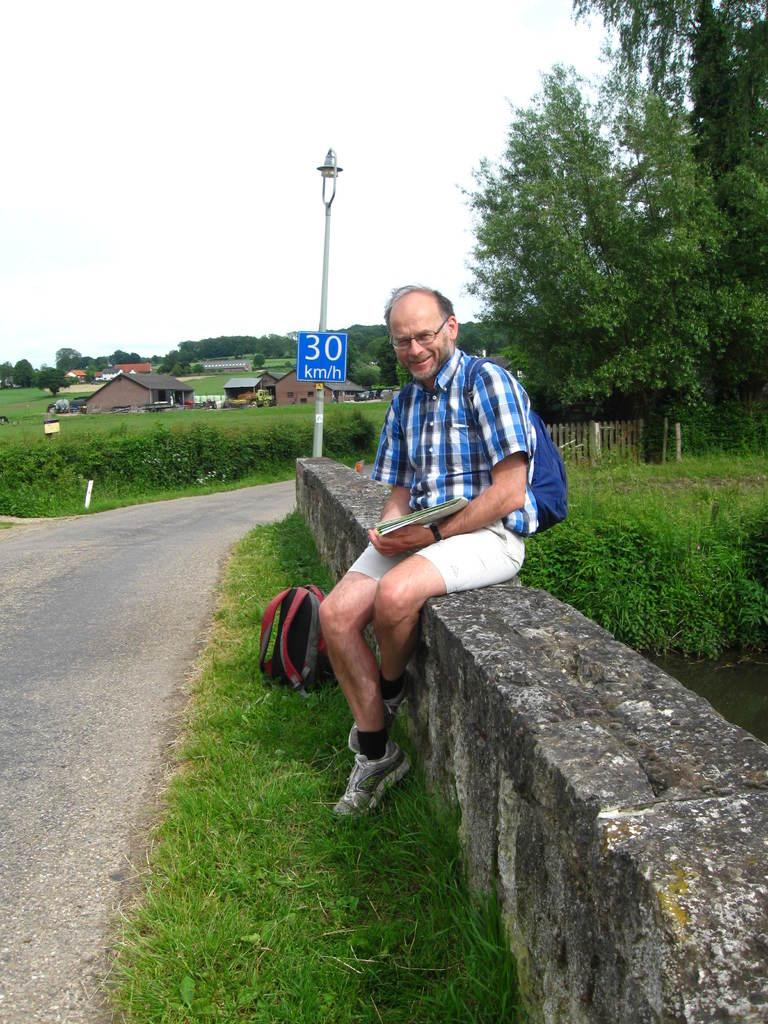<image>
Render a clear and concise summary of the photo. A man sitting on a retaining wall in front of a speed limit sign for 30 kilometers per hour. 